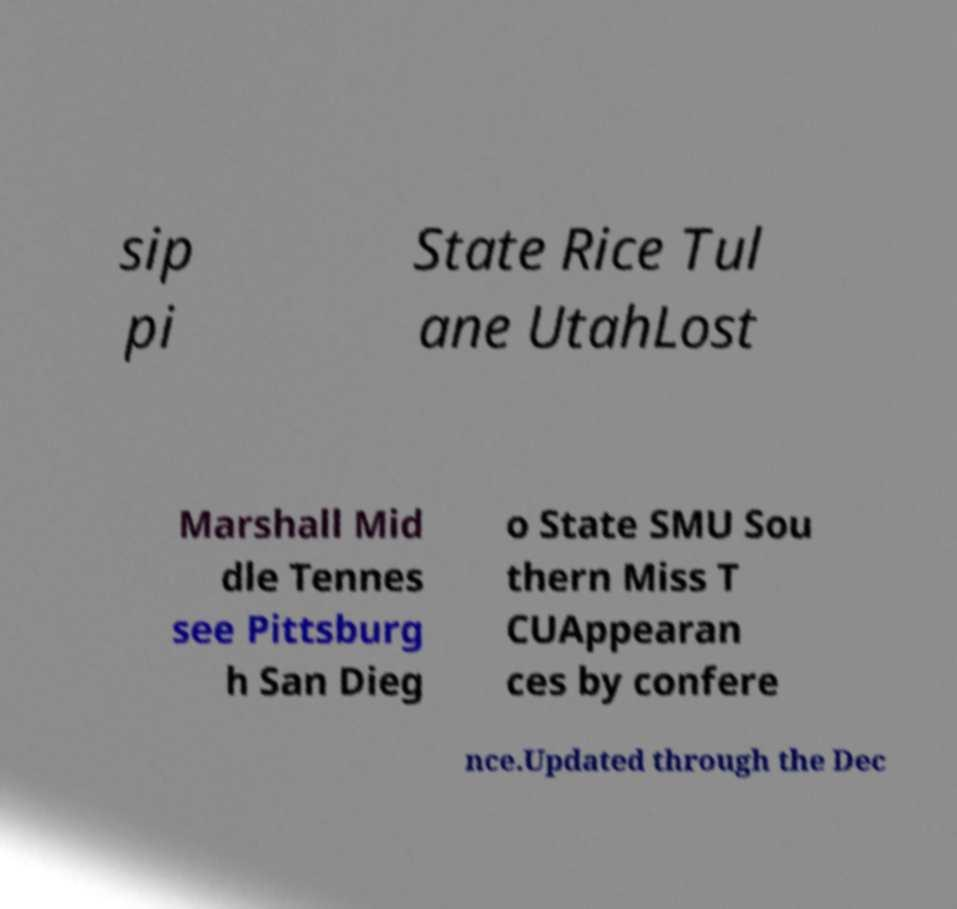For documentation purposes, I need the text within this image transcribed. Could you provide that? sip pi State Rice Tul ane UtahLost Marshall Mid dle Tennes see Pittsburg h San Dieg o State SMU Sou thern Miss T CUAppearan ces by confere nce.Updated through the Dec 